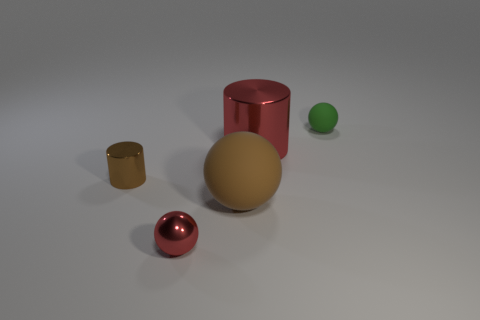Add 3 gray rubber spheres. How many objects exist? 8 Subtract all balls. How many objects are left? 2 Subtract 0 green cylinders. How many objects are left? 5 Subtract all big spheres. Subtract all brown rubber objects. How many objects are left? 3 Add 4 tiny things. How many tiny things are left? 7 Add 3 small rubber spheres. How many small rubber spheres exist? 4 